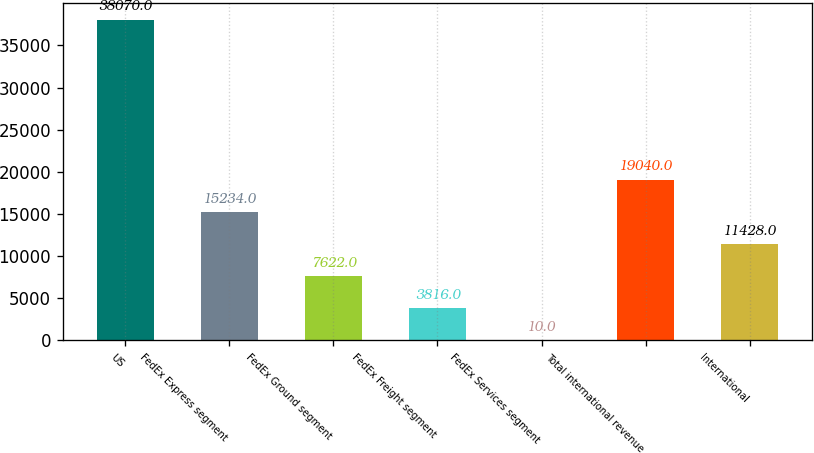Convert chart to OTSL. <chart><loc_0><loc_0><loc_500><loc_500><bar_chart><fcel>US<fcel>FedEx Express segment<fcel>FedEx Ground segment<fcel>FedEx Freight segment<fcel>FedEx Services segment<fcel>Total international revenue<fcel>International<nl><fcel>38070<fcel>15234<fcel>7622<fcel>3816<fcel>10<fcel>19040<fcel>11428<nl></chart> 